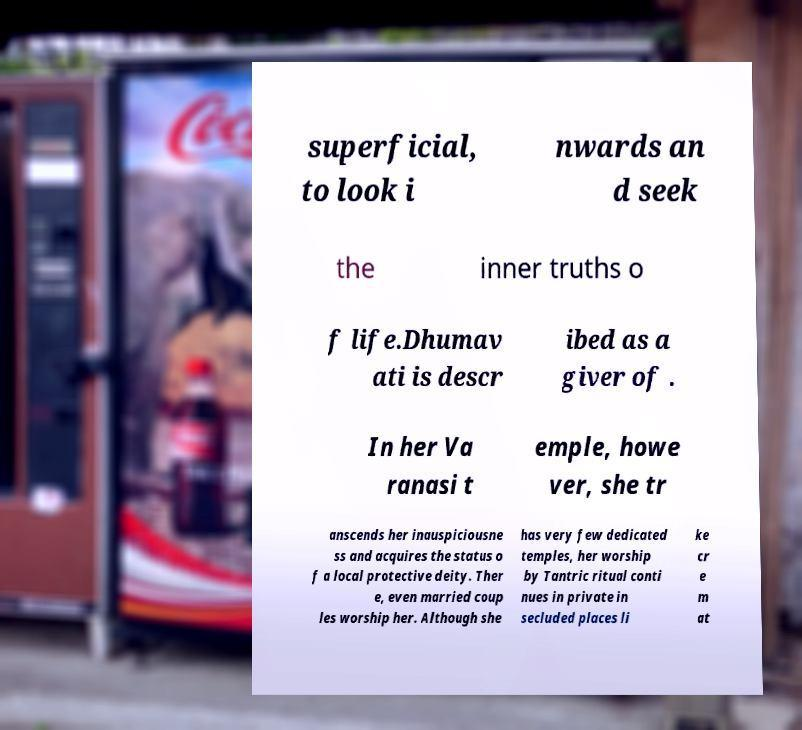What messages or text are displayed in this image? I need them in a readable, typed format. superficial, to look i nwards an d seek the inner truths o f life.Dhumav ati is descr ibed as a giver of . In her Va ranasi t emple, howe ver, she tr anscends her inauspiciousne ss and acquires the status o f a local protective deity. Ther e, even married coup les worship her. Although she has very few dedicated temples, her worship by Tantric ritual conti nues in private in secluded places li ke cr e m at 